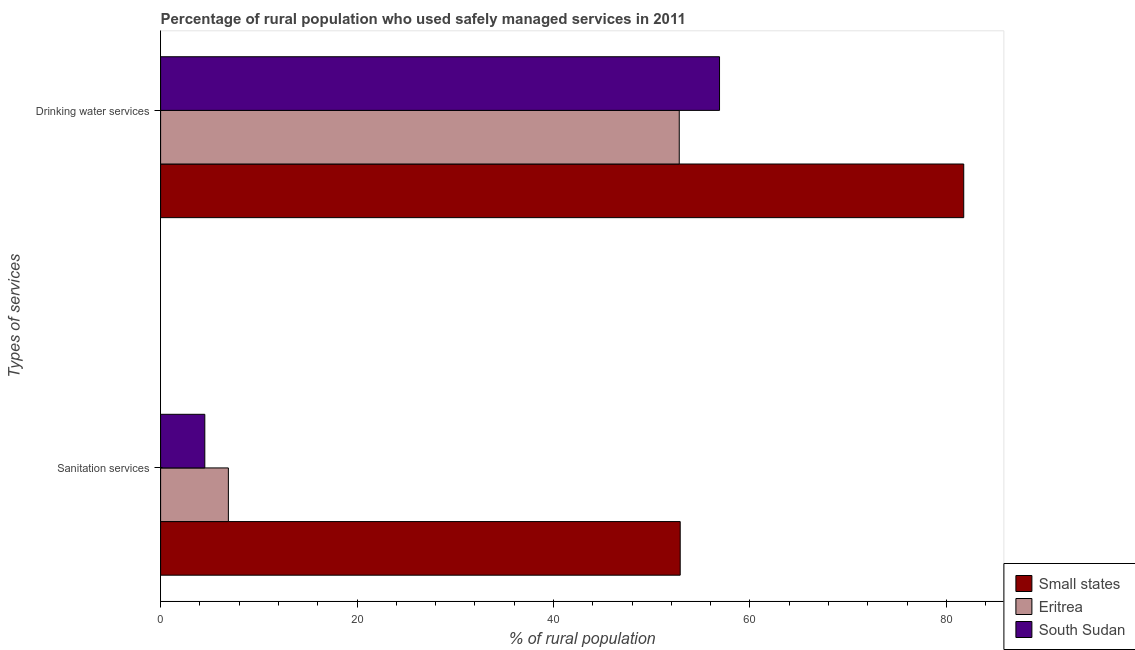How many different coloured bars are there?
Provide a succinct answer. 3. How many groups of bars are there?
Your answer should be very brief. 2. Are the number of bars on each tick of the Y-axis equal?
Ensure brevity in your answer.  Yes. How many bars are there on the 1st tick from the bottom?
Your answer should be compact. 3. What is the label of the 2nd group of bars from the top?
Your response must be concise. Sanitation services. What is the percentage of rural population who used drinking water services in South Sudan?
Your answer should be compact. 56.9. Across all countries, what is the maximum percentage of rural population who used drinking water services?
Make the answer very short. 81.76. Across all countries, what is the minimum percentage of rural population who used drinking water services?
Make the answer very short. 52.8. In which country was the percentage of rural population who used sanitation services maximum?
Your response must be concise. Small states. In which country was the percentage of rural population who used sanitation services minimum?
Your answer should be compact. South Sudan. What is the total percentage of rural population who used drinking water services in the graph?
Offer a terse response. 191.46. What is the difference between the percentage of rural population who used drinking water services in South Sudan and that in Eritrea?
Your response must be concise. 4.1. What is the difference between the percentage of rural population who used drinking water services in South Sudan and the percentage of rural population who used sanitation services in Eritrea?
Your response must be concise. 50. What is the average percentage of rural population who used sanitation services per country?
Keep it short and to the point. 21.43. What is the difference between the percentage of rural population who used drinking water services and percentage of rural population who used sanitation services in Eritrea?
Provide a short and direct response. 45.9. What is the ratio of the percentage of rural population who used drinking water services in South Sudan to that in Eritrea?
Your answer should be very brief. 1.08. Is the percentage of rural population who used drinking water services in South Sudan less than that in Small states?
Provide a short and direct response. Yes. In how many countries, is the percentage of rural population who used sanitation services greater than the average percentage of rural population who used sanitation services taken over all countries?
Your response must be concise. 1. What does the 3rd bar from the top in Drinking water services represents?
Offer a terse response. Small states. What does the 1st bar from the bottom in Drinking water services represents?
Provide a succinct answer. Small states. Are all the bars in the graph horizontal?
Ensure brevity in your answer.  Yes. What is the difference between two consecutive major ticks on the X-axis?
Ensure brevity in your answer.  20. Does the graph contain grids?
Offer a terse response. No. How many legend labels are there?
Provide a succinct answer. 3. What is the title of the graph?
Provide a short and direct response. Percentage of rural population who used safely managed services in 2011. What is the label or title of the X-axis?
Make the answer very short. % of rural population. What is the label or title of the Y-axis?
Offer a very short reply. Types of services. What is the % of rural population in Small states in Sanitation services?
Keep it short and to the point. 52.9. What is the % of rural population of Small states in Drinking water services?
Provide a succinct answer. 81.76. What is the % of rural population in Eritrea in Drinking water services?
Ensure brevity in your answer.  52.8. What is the % of rural population of South Sudan in Drinking water services?
Your answer should be very brief. 56.9. Across all Types of services, what is the maximum % of rural population of Small states?
Provide a short and direct response. 81.76. Across all Types of services, what is the maximum % of rural population in Eritrea?
Your response must be concise. 52.8. Across all Types of services, what is the maximum % of rural population of South Sudan?
Offer a very short reply. 56.9. Across all Types of services, what is the minimum % of rural population in Small states?
Your response must be concise. 52.9. What is the total % of rural population in Small states in the graph?
Your response must be concise. 134.66. What is the total % of rural population in Eritrea in the graph?
Your answer should be very brief. 59.7. What is the total % of rural population in South Sudan in the graph?
Offer a terse response. 61.4. What is the difference between the % of rural population in Small states in Sanitation services and that in Drinking water services?
Offer a very short reply. -28.86. What is the difference between the % of rural population in Eritrea in Sanitation services and that in Drinking water services?
Make the answer very short. -45.9. What is the difference between the % of rural population in South Sudan in Sanitation services and that in Drinking water services?
Provide a succinct answer. -52.4. What is the difference between the % of rural population of Small states in Sanitation services and the % of rural population of Eritrea in Drinking water services?
Your answer should be very brief. 0.1. What is the difference between the % of rural population of Small states in Sanitation services and the % of rural population of South Sudan in Drinking water services?
Keep it short and to the point. -4. What is the average % of rural population of Small states per Types of services?
Give a very brief answer. 67.33. What is the average % of rural population of Eritrea per Types of services?
Give a very brief answer. 29.85. What is the average % of rural population of South Sudan per Types of services?
Your answer should be compact. 30.7. What is the difference between the % of rural population in Small states and % of rural population in Eritrea in Sanitation services?
Make the answer very short. 46. What is the difference between the % of rural population of Small states and % of rural population of South Sudan in Sanitation services?
Provide a short and direct response. 48.4. What is the difference between the % of rural population of Eritrea and % of rural population of South Sudan in Sanitation services?
Your answer should be very brief. 2.4. What is the difference between the % of rural population of Small states and % of rural population of Eritrea in Drinking water services?
Provide a short and direct response. 28.96. What is the difference between the % of rural population of Small states and % of rural population of South Sudan in Drinking water services?
Your answer should be very brief. 24.86. What is the difference between the % of rural population in Eritrea and % of rural population in South Sudan in Drinking water services?
Your answer should be compact. -4.1. What is the ratio of the % of rural population in Small states in Sanitation services to that in Drinking water services?
Offer a very short reply. 0.65. What is the ratio of the % of rural population in Eritrea in Sanitation services to that in Drinking water services?
Offer a terse response. 0.13. What is the ratio of the % of rural population of South Sudan in Sanitation services to that in Drinking water services?
Provide a short and direct response. 0.08. What is the difference between the highest and the second highest % of rural population in Small states?
Your response must be concise. 28.86. What is the difference between the highest and the second highest % of rural population in Eritrea?
Make the answer very short. 45.9. What is the difference between the highest and the second highest % of rural population of South Sudan?
Your answer should be very brief. 52.4. What is the difference between the highest and the lowest % of rural population of Small states?
Provide a short and direct response. 28.86. What is the difference between the highest and the lowest % of rural population of Eritrea?
Your answer should be compact. 45.9. What is the difference between the highest and the lowest % of rural population of South Sudan?
Offer a terse response. 52.4. 